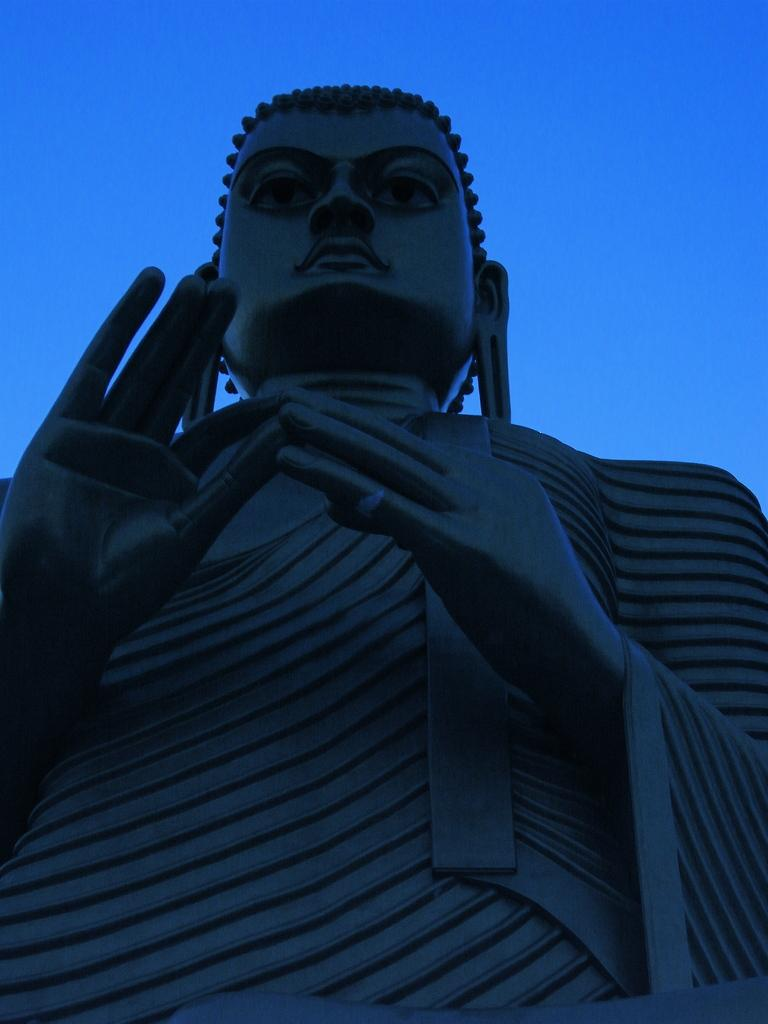What is the main subject in the image? There is a statue in the image. What is the color of the statue? The statue is in black color. What is the condition of the sky in the image? The sky is clear in the image. Can you see any stars in the image? There are no stars visible in the image. Is the statue shown slipping off the edge in the image? There is no indication of the statue slipping off the edge in the image. 